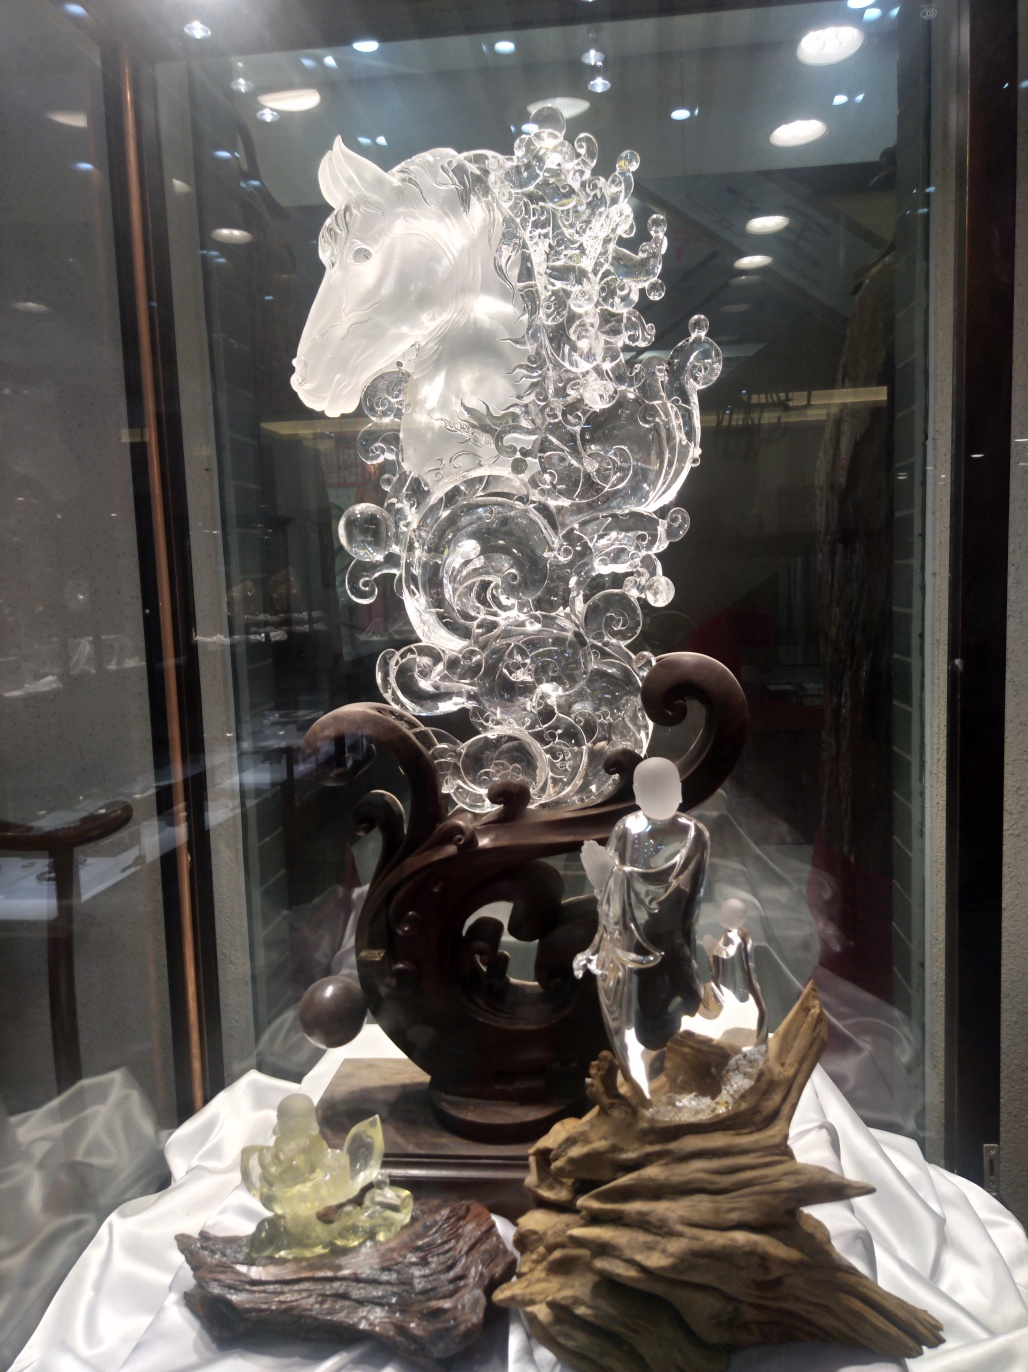Can you describe what's in this image? The image features a beautifully crafted glass sculpture of a horse surrounded by intricate embellishments. It rests on an elegant wooden base and is accompanied by other smaller glass figurines and natural elements like wood and stone, all presented under a protective display case. 